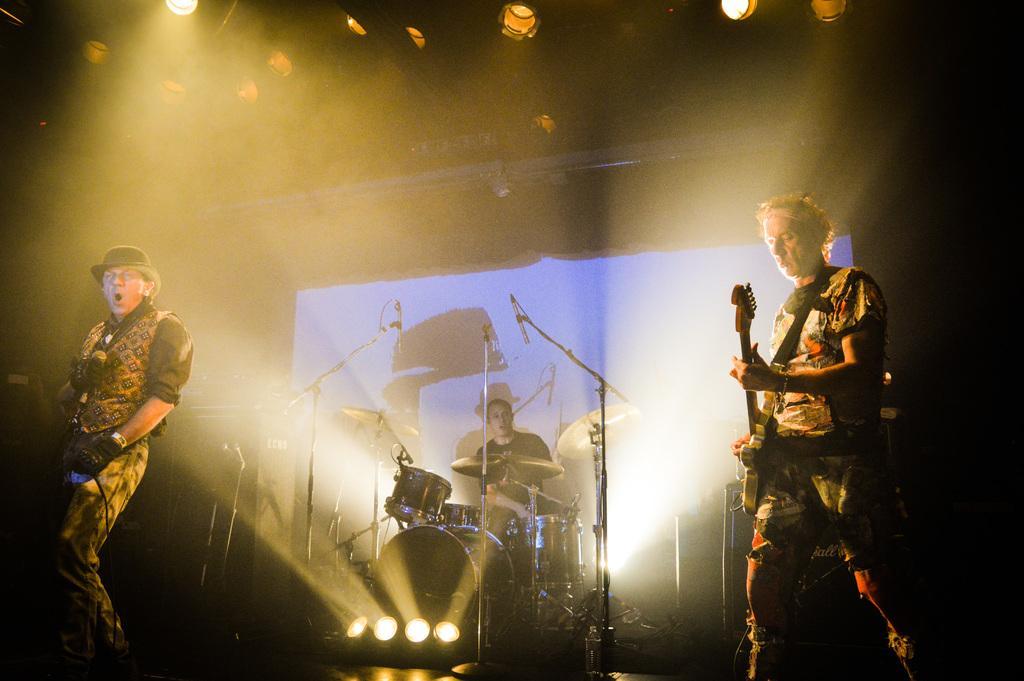In one or two sentences, can you explain what this image depicts? In this image I see a man who is holding a mic, another man holding a guitar and in the background I see a man who is with the drums and I see the lights. 